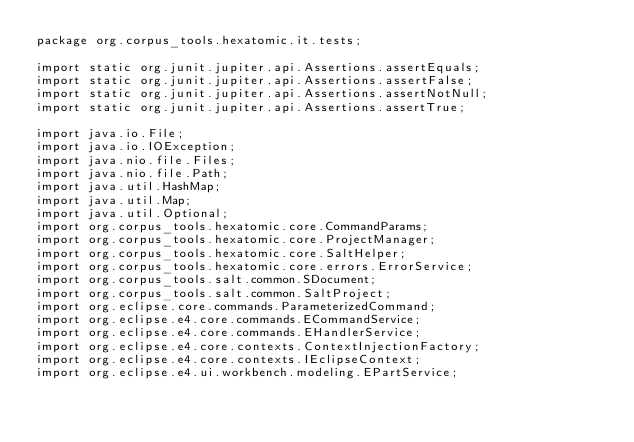Convert code to text. <code><loc_0><loc_0><loc_500><loc_500><_Java_>package org.corpus_tools.hexatomic.it.tests;

import static org.junit.jupiter.api.Assertions.assertEquals;
import static org.junit.jupiter.api.Assertions.assertFalse;
import static org.junit.jupiter.api.Assertions.assertNotNull;
import static org.junit.jupiter.api.Assertions.assertTrue;

import java.io.File;
import java.io.IOException;
import java.nio.file.Files;
import java.nio.file.Path;
import java.util.HashMap;
import java.util.Map;
import java.util.Optional;
import org.corpus_tools.hexatomic.core.CommandParams;
import org.corpus_tools.hexatomic.core.ProjectManager;
import org.corpus_tools.hexatomic.core.SaltHelper;
import org.corpus_tools.hexatomic.core.errors.ErrorService;
import org.corpus_tools.salt.common.SDocument;
import org.corpus_tools.salt.common.SaltProject;
import org.eclipse.core.commands.ParameterizedCommand;
import org.eclipse.e4.core.commands.ECommandService;
import org.eclipse.e4.core.commands.EHandlerService;
import org.eclipse.e4.core.contexts.ContextInjectionFactory;
import org.eclipse.e4.core.contexts.IEclipseContext;
import org.eclipse.e4.ui.workbench.modeling.EPartService;</code> 